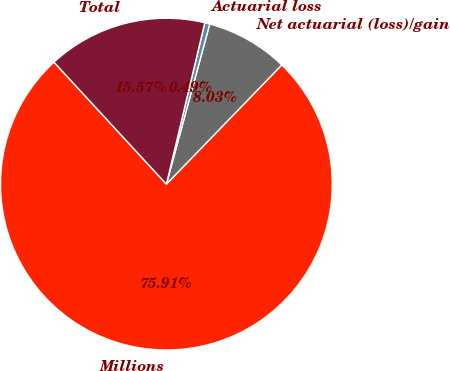Convert chart to OTSL. <chart><loc_0><loc_0><loc_500><loc_500><pie_chart><fcel>Millions<fcel>Net actuarial (loss)/gain<fcel>Actuarial loss<fcel>Total<nl><fcel>75.91%<fcel>8.03%<fcel>0.49%<fcel>15.57%<nl></chart> 